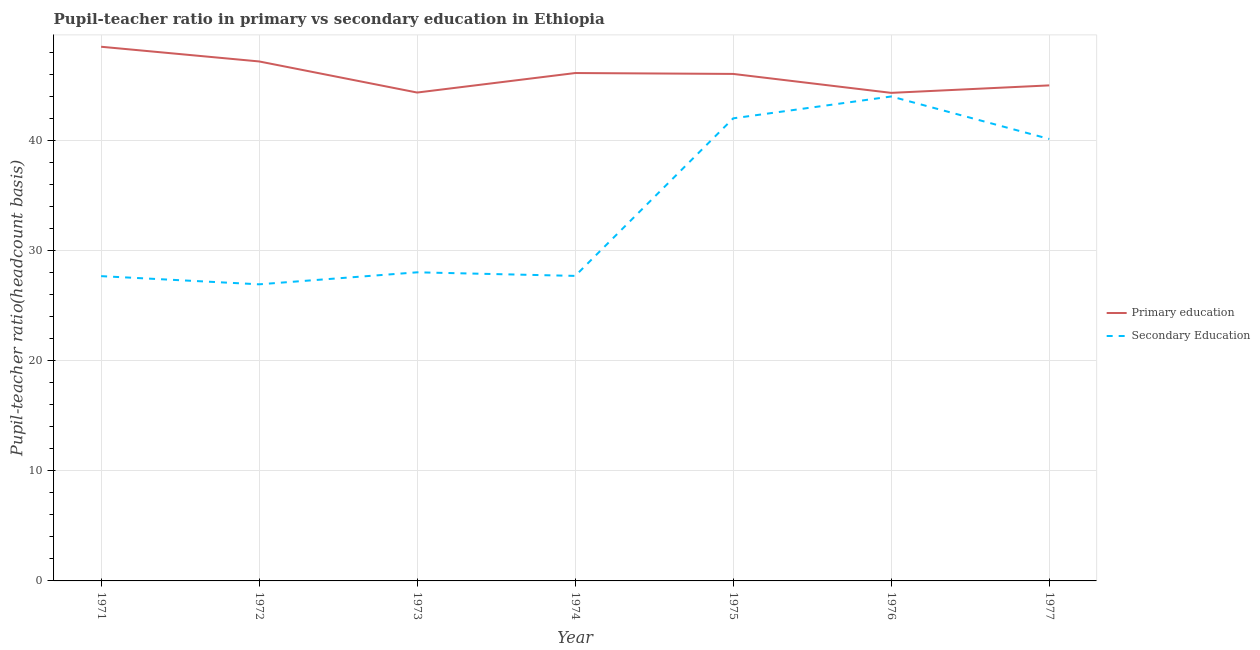How many different coloured lines are there?
Give a very brief answer. 2. What is the pupil teacher ratio on secondary education in 1977?
Give a very brief answer. 40.13. Across all years, what is the maximum pupil teacher ratio on secondary education?
Provide a succinct answer. 43.98. Across all years, what is the minimum pupil teacher ratio on secondary education?
Offer a terse response. 26.93. In which year was the pupil-teacher ratio in primary education maximum?
Make the answer very short. 1971. In which year was the pupil-teacher ratio in primary education minimum?
Your answer should be compact. 1976. What is the total pupil teacher ratio on secondary education in the graph?
Offer a very short reply. 236.43. What is the difference between the pupil teacher ratio on secondary education in 1972 and that in 1974?
Your answer should be compact. -0.76. What is the difference between the pupil teacher ratio on secondary education in 1971 and the pupil-teacher ratio in primary education in 1977?
Provide a short and direct response. -17.32. What is the average pupil-teacher ratio in primary education per year?
Keep it short and to the point. 45.92. In the year 1977, what is the difference between the pupil-teacher ratio in primary education and pupil teacher ratio on secondary education?
Keep it short and to the point. 4.86. What is the ratio of the pupil-teacher ratio in primary education in 1972 to that in 1976?
Your answer should be very brief. 1.06. What is the difference between the highest and the second highest pupil-teacher ratio in primary education?
Ensure brevity in your answer.  1.33. What is the difference between the highest and the lowest pupil teacher ratio on secondary education?
Give a very brief answer. 17.05. Is the pupil-teacher ratio in primary education strictly greater than the pupil teacher ratio on secondary education over the years?
Ensure brevity in your answer.  Yes. How many lines are there?
Keep it short and to the point. 2. Are the values on the major ticks of Y-axis written in scientific E-notation?
Your response must be concise. No. Does the graph contain grids?
Your answer should be compact. Yes. How are the legend labels stacked?
Provide a short and direct response. Vertical. What is the title of the graph?
Give a very brief answer. Pupil-teacher ratio in primary vs secondary education in Ethiopia. Does "Excluding technical cooperation" appear as one of the legend labels in the graph?
Ensure brevity in your answer.  No. What is the label or title of the X-axis?
Your response must be concise. Year. What is the label or title of the Y-axis?
Offer a very short reply. Pupil-teacher ratio(headcount basis). What is the Pupil-teacher ratio(headcount basis) of Primary education in 1971?
Provide a short and direct response. 48.5. What is the Pupil-teacher ratio(headcount basis) in Secondary Education in 1971?
Make the answer very short. 27.67. What is the Pupil-teacher ratio(headcount basis) of Primary education in 1972?
Your answer should be very brief. 47.17. What is the Pupil-teacher ratio(headcount basis) of Secondary Education in 1972?
Your answer should be very brief. 26.93. What is the Pupil-teacher ratio(headcount basis) in Primary education in 1973?
Offer a very short reply. 44.34. What is the Pupil-teacher ratio(headcount basis) in Secondary Education in 1973?
Offer a terse response. 28.02. What is the Pupil-teacher ratio(headcount basis) in Primary education in 1974?
Offer a very short reply. 46.11. What is the Pupil-teacher ratio(headcount basis) of Secondary Education in 1974?
Your answer should be compact. 27.69. What is the Pupil-teacher ratio(headcount basis) of Primary education in 1975?
Give a very brief answer. 46.03. What is the Pupil-teacher ratio(headcount basis) in Secondary Education in 1975?
Keep it short and to the point. 42. What is the Pupil-teacher ratio(headcount basis) in Primary education in 1976?
Ensure brevity in your answer.  44.31. What is the Pupil-teacher ratio(headcount basis) of Secondary Education in 1976?
Your response must be concise. 43.98. What is the Pupil-teacher ratio(headcount basis) in Primary education in 1977?
Give a very brief answer. 44.99. What is the Pupil-teacher ratio(headcount basis) in Secondary Education in 1977?
Offer a terse response. 40.13. Across all years, what is the maximum Pupil-teacher ratio(headcount basis) of Primary education?
Offer a very short reply. 48.5. Across all years, what is the maximum Pupil-teacher ratio(headcount basis) of Secondary Education?
Give a very brief answer. 43.98. Across all years, what is the minimum Pupil-teacher ratio(headcount basis) of Primary education?
Your response must be concise. 44.31. Across all years, what is the minimum Pupil-teacher ratio(headcount basis) in Secondary Education?
Offer a very short reply. 26.93. What is the total Pupil-teacher ratio(headcount basis) in Primary education in the graph?
Offer a very short reply. 321.46. What is the total Pupil-teacher ratio(headcount basis) of Secondary Education in the graph?
Keep it short and to the point. 236.43. What is the difference between the Pupil-teacher ratio(headcount basis) of Primary education in 1971 and that in 1972?
Your answer should be very brief. 1.33. What is the difference between the Pupil-teacher ratio(headcount basis) of Secondary Education in 1971 and that in 1972?
Your answer should be very brief. 0.74. What is the difference between the Pupil-teacher ratio(headcount basis) of Primary education in 1971 and that in 1973?
Offer a very short reply. 4.16. What is the difference between the Pupil-teacher ratio(headcount basis) of Secondary Education in 1971 and that in 1973?
Ensure brevity in your answer.  -0.35. What is the difference between the Pupil-teacher ratio(headcount basis) in Primary education in 1971 and that in 1974?
Give a very brief answer. 2.39. What is the difference between the Pupil-teacher ratio(headcount basis) in Secondary Education in 1971 and that in 1974?
Your response must be concise. -0.02. What is the difference between the Pupil-teacher ratio(headcount basis) of Primary education in 1971 and that in 1975?
Your answer should be very brief. 2.47. What is the difference between the Pupil-teacher ratio(headcount basis) of Secondary Education in 1971 and that in 1975?
Ensure brevity in your answer.  -14.33. What is the difference between the Pupil-teacher ratio(headcount basis) in Primary education in 1971 and that in 1976?
Offer a terse response. 4.19. What is the difference between the Pupil-teacher ratio(headcount basis) of Secondary Education in 1971 and that in 1976?
Provide a succinct answer. -16.31. What is the difference between the Pupil-teacher ratio(headcount basis) in Primary education in 1971 and that in 1977?
Your answer should be very brief. 3.51. What is the difference between the Pupil-teacher ratio(headcount basis) of Secondary Education in 1971 and that in 1977?
Ensure brevity in your answer.  -12.46. What is the difference between the Pupil-teacher ratio(headcount basis) of Primary education in 1972 and that in 1973?
Your answer should be very brief. 2.82. What is the difference between the Pupil-teacher ratio(headcount basis) of Secondary Education in 1972 and that in 1973?
Your answer should be compact. -1.09. What is the difference between the Pupil-teacher ratio(headcount basis) in Primary education in 1972 and that in 1974?
Your answer should be compact. 1.05. What is the difference between the Pupil-teacher ratio(headcount basis) in Secondary Education in 1972 and that in 1974?
Offer a terse response. -0.76. What is the difference between the Pupil-teacher ratio(headcount basis) of Primary education in 1972 and that in 1975?
Make the answer very short. 1.13. What is the difference between the Pupil-teacher ratio(headcount basis) of Secondary Education in 1972 and that in 1975?
Your answer should be compact. -15.07. What is the difference between the Pupil-teacher ratio(headcount basis) in Primary education in 1972 and that in 1976?
Provide a short and direct response. 2.85. What is the difference between the Pupil-teacher ratio(headcount basis) of Secondary Education in 1972 and that in 1976?
Your answer should be compact. -17.05. What is the difference between the Pupil-teacher ratio(headcount basis) in Primary education in 1972 and that in 1977?
Provide a short and direct response. 2.17. What is the difference between the Pupil-teacher ratio(headcount basis) in Secondary Education in 1972 and that in 1977?
Provide a succinct answer. -13.2. What is the difference between the Pupil-teacher ratio(headcount basis) in Primary education in 1973 and that in 1974?
Offer a terse response. -1.77. What is the difference between the Pupil-teacher ratio(headcount basis) of Secondary Education in 1973 and that in 1974?
Keep it short and to the point. 0.33. What is the difference between the Pupil-teacher ratio(headcount basis) in Primary education in 1973 and that in 1975?
Provide a short and direct response. -1.69. What is the difference between the Pupil-teacher ratio(headcount basis) in Secondary Education in 1973 and that in 1975?
Provide a short and direct response. -13.98. What is the difference between the Pupil-teacher ratio(headcount basis) in Primary education in 1973 and that in 1976?
Provide a succinct answer. 0.03. What is the difference between the Pupil-teacher ratio(headcount basis) in Secondary Education in 1973 and that in 1976?
Offer a terse response. -15.96. What is the difference between the Pupil-teacher ratio(headcount basis) of Primary education in 1973 and that in 1977?
Provide a succinct answer. -0.65. What is the difference between the Pupil-teacher ratio(headcount basis) in Secondary Education in 1973 and that in 1977?
Keep it short and to the point. -12.11. What is the difference between the Pupil-teacher ratio(headcount basis) in Primary education in 1974 and that in 1975?
Offer a very short reply. 0.08. What is the difference between the Pupil-teacher ratio(headcount basis) in Secondary Education in 1974 and that in 1975?
Offer a very short reply. -14.31. What is the difference between the Pupil-teacher ratio(headcount basis) in Primary education in 1974 and that in 1976?
Keep it short and to the point. 1.8. What is the difference between the Pupil-teacher ratio(headcount basis) of Secondary Education in 1974 and that in 1976?
Your answer should be very brief. -16.29. What is the difference between the Pupil-teacher ratio(headcount basis) in Primary education in 1974 and that in 1977?
Make the answer very short. 1.12. What is the difference between the Pupil-teacher ratio(headcount basis) in Secondary Education in 1974 and that in 1977?
Your answer should be very brief. -12.43. What is the difference between the Pupil-teacher ratio(headcount basis) of Primary education in 1975 and that in 1976?
Your answer should be very brief. 1.72. What is the difference between the Pupil-teacher ratio(headcount basis) in Secondary Education in 1975 and that in 1976?
Offer a very short reply. -1.98. What is the difference between the Pupil-teacher ratio(headcount basis) of Primary education in 1975 and that in 1977?
Make the answer very short. 1.04. What is the difference between the Pupil-teacher ratio(headcount basis) of Secondary Education in 1975 and that in 1977?
Your response must be concise. 1.87. What is the difference between the Pupil-teacher ratio(headcount basis) of Primary education in 1976 and that in 1977?
Ensure brevity in your answer.  -0.68. What is the difference between the Pupil-teacher ratio(headcount basis) in Secondary Education in 1976 and that in 1977?
Give a very brief answer. 3.86. What is the difference between the Pupil-teacher ratio(headcount basis) in Primary education in 1971 and the Pupil-teacher ratio(headcount basis) in Secondary Education in 1972?
Keep it short and to the point. 21.57. What is the difference between the Pupil-teacher ratio(headcount basis) of Primary education in 1971 and the Pupil-teacher ratio(headcount basis) of Secondary Education in 1973?
Offer a very short reply. 20.48. What is the difference between the Pupil-teacher ratio(headcount basis) in Primary education in 1971 and the Pupil-teacher ratio(headcount basis) in Secondary Education in 1974?
Ensure brevity in your answer.  20.8. What is the difference between the Pupil-teacher ratio(headcount basis) in Primary education in 1971 and the Pupil-teacher ratio(headcount basis) in Secondary Education in 1975?
Ensure brevity in your answer.  6.5. What is the difference between the Pupil-teacher ratio(headcount basis) in Primary education in 1971 and the Pupil-teacher ratio(headcount basis) in Secondary Education in 1976?
Provide a succinct answer. 4.51. What is the difference between the Pupil-teacher ratio(headcount basis) of Primary education in 1971 and the Pupil-teacher ratio(headcount basis) of Secondary Education in 1977?
Make the answer very short. 8.37. What is the difference between the Pupil-teacher ratio(headcount basis) in Primary education in 1972 and the Pupil-teacher ratio(headcount basis) in Secondary Education in 1973?
Make the answer very short. 19.15. What is the difference between the Pupil-teacher ratio(headcount basis) in Primary education in 1972 and the Pupil-teacher ratio(headcount basis) in Secondary Education in 1974?
Ensure brevity in your answer.  19.47. What is the difference between the Pupil-teacher ratio(headcount basis) in Primary education in 1972 and the Pupil-teacher ratio(headcount basis) in Secondary Education in 1975?
Ensure brevity in your answer.  5.17. What is the difference between the Pupil-teacher ratio(headcount basis) of Primary education in 1972 and the Pupil-teacher ratio(headcount basis) of Secondary Education in 1976?
Offer a terse response. 3.18. What is the difference between the Pupil-teacher ratio(headcount basis) of Primary education in 1972 and the Pupil-teacher ratio(headcount basis) of Secondary Education in 1977?
Keep it short and to the point. 7.04. What is the difference between the Pupil-teacher ratio(headcount basis) in Primary education in 1973 and the Pupil-teacher ratio(headcount basis) in Secondary Education in 1974?
Provide a short and direct response. 16.65. What is the difference between the Pupil-teacher ratio(headcount basis) of Primary education in 1973 and the Pupil-teacher ratio(headcount basis) of Secondary Education in 1975?
Keep it short and to the point. 2.34. What is the difference between the Pupil-teacher ratio(headcount basis) in Primary education in 1973 and the Pupil-teacher ratio(headcount basis) in Secondary Education in 1976?
Provide a succinct answer. 0.36. What is the difference between the Pupil-teacher ratio(headcount basis) of Primary education in 1973 and the Pupil-teacher ratio(headcount basis) of Secondary Education in 1977?
Your response must be concise. 4.21. What is the difference between the Pupil-teacher ratio(headcount basis) of Primary education in 1974 and the Pupil-teacher ratio(headcount basis) of Secondary Education in 1975?
Ensure brevity in your answer.  4.11. What is the difference between the Pupil-teacher ratio(headcount basis) of Primary education in 1974 and the Pupil-teacher ratio(headcount basis) of Secondary Education in 1976?
Ensure brevity in your answer.  2.13. What is the difference between the Pupil-teacher ratio(headcount basis) in Primary education in 1974 and the Pupil-teacher ratio(headcount basis) in Secondary Education in 1977?
Offer a very short reply. 5.99. What is the difference between the Pupil-teacher ratio(headcount basis) in Primary education in 1975 and the Pupil-teacher ratio(headcount basis) in Secondary Education in 1976?
Your answer should be compact. 2.05. What is the difference between the Pupil-teacher ratio(headcount basis) of Primary education in 1975 and the Pupil-teacher ratio(headcount basis) of Secondary Education in 1977?
Your answer should be very brief. 5.91. What is the difference between the Pupil-teacher ratio(headcount basis) of Primary education in 1976 and the Pupil-teacher ratio(headcount basis) of Secondary Education in 1977?
Keep it short and to the point. 4.19. What is the average Pupil-teacher ratio(headcount basis) in Primary education per year?
Make the answer very short. 45.92. What is the average Pupil-teacher ratio(headcount basis) of Secondary Education per year?
Make the answer very short. 33.78. In the year 1971, what is the difference between the Pupil-teacher ratio(headcount basis) in Primary education and Pupil-teacher ratio(headcount basis) in Secondary Education?
Ensure brevity in your answer.  20.83. In the year 1972, what is the difference between the Pupil-teacher ratio(headcount basis) of Primary education and Pupil-teacher ratio(headcount basis) of Secondary Education?
Offer a very short reply. 20.24. In the year 1973, what is the difference between the Pupil-teacher ratio(headcount basis) of Primary education and Pupil-teacher ratio(headcount basis) of Secondary Education?
Offer a terse response. 16.32. In the year 1974, what is the difference between the Pupil-teacher ratio(headcount basis) in Primary education and Pupil-teacher ratio(headcount basis) in Secondary Education?
Your response must be concise. 18.42. In the year 1975, what is the difference between the Pupil-teacher ratio(headcount basis) in Primary education and Pupil-teacher ratio(headcount basis) in Secondary Education?
Make the answer very short. 4.03. In the year 1976, what is the difference between the Pupil-teacher ratio(headcount basis) of Primary education and Pupil-teacher ratio(headcount basis) of Secondary Education?
Keep it short and to the point. 0.33. In the year 1977, what is the difference between the Pupil-teacher ratio(headcount basis) of Primary education and Pupil-teacher ratio(headcount basis) of Secondary Education?
Keep it short and to the point. 4.86. What is the ratio of the Pupil-teacher ratio(headcount basis) of Primary education in 1971 to that in 1972?
Keep it short and to the point. 1.03. What is the ratio of the Pupil-teacher ratio(headcount basis) of Secondary Education in 1971 to that in 1972?
Make the answer very short. 1.03. What is the ratio of the Pupil-teacher ratio(headcount basis) in Primary education in 1971 to that in 1973?
Provide a short and direct response. 1.09. What is the ratio of the Pupil-teacher ratio(headcount basis) in Secondary Education in 1971 to that in 1973?
Provide a short and direct response. 0.99. What is the ratio of the Pupil-teacher ratio(headcount basis) of Primary education in 1971 to that in 1974?
Your response must be concise. 1.05. What is the ratio of the Pupil-teacher ratio(headcount basis) in Primary education in 1971 to that in 1975?
Ensure brevity in your answer.  1.05. What is the ratio of the Pupil-teacher ratio(headcount basis) of Secondary Education in 1971 to that in 1975?
Give a very brief answer. 0.66. What is the ratio of the Pupil-teacher ratio(headcount basis) in Primary education in 1971 to that in 1976?
Give a very brief answer. 1.09. What is the ratio of the Pupil-teacher ratio(headcount basis) of Secondary Education in 1971 to that in 1976?
Give a very brief answer. 0.63. What is the ratio of the Pupil-teacher ratio(headcount basis) of Primary education in 1971 to that in 1977?
Offer a very short reply. 1.08. What is the ratio of the Pupil-teacher ratio(headcount basis) of Secondary Education in 1971 to that in 1977?
Give a very brief answer. 0.69. What is the ratio of the Pupil-teacher ratio(headcount basis) of Primary education in 1972 to that in 1973?
Your response must be concise. 1.06. What is the ratio of the Pupil-teacher ratio(headcount basis) in Secondary Education in 1972 to that in 1973?
Keep it short and to the point. 0.96. What is the ratio of the Pupil-teacher ratio(headcount basis) of Primary education in 1972 to that in 1974?
Keep it short and to the point. 1.02. What is the ratio of the Pupil-teacher ratio(headcount basis) in Secondary Education in 1972 to that in 1974?
Your response must be concise. 0.97. What is the ratio of the Pupil-teacher ratio(headcount basis) of Primary education in 1972 to that in 1975?
Keep it short and to the point. 1.02. What is the ratio of the Pupil-teacher ratio(headcount basis) in Secondary Education in 1972 to that in 1975?
Provide a succinct answer. 0.64. What is the ratio of the Pupil-teacher ratio(headcount basis) in Primary education in 1972 to that in 1976?
Give a very brief answer. 1.06. What is the ratio of the Pupil-teacher ratio(headcount basis) in Secondary Education in 1972 to that in 1976?
Your answer should be compact. 0.61. What is the ratio of the Pupil-teacher ratio(headcount basis) of Primary education in 1972 to that in 1977?
Ensure brevity in your answer.  1.05. What is the ratio of the Pupil-teacher ratio(headcount basis) in Secondary Education in 1972 to that in 1977?
Offer a terse response. 0.67. What is the ratio of the Pupil-teacher ratio(headcount basis) of Primary education in 1973 to that in 1974?
Offer a terse response. 0.96. What is the ratio of the Pupil-teacher ratio(headcount basis) of Secondary Education in 1973 to that in 1974?
Provide a succinct answer. 1.01. What is the ratio of the Pupil-teacher ratio(headcount basis) of Primary education in 1973 to that in 1975?
Offer a terse response. 0.96. What is the ratio of the Pupil-teacher ratio(headcount basis) in Secondary Education in 1973 to that in 1975?
Provide a succinct answer. 0.67. What is the ratio of the Pupil-teacher ratio(headcount basis) in Primary education in 1973 to that in 1976?
Your answer should be very brief. 1. What is the ratio of the Pupil-teacher ratio(headcount basis) of Secondary Education in 1973 to that in 1976?
Provide a short and direct response. 0.64. What is the ratio of the Pupil-teacher ratio(headcount basis) of Primary education in 1973 to that in 1977?
Your answer should be very brief. 0.99. What is the ratio of the Pupil-teacher ratio(headcount basis) of Secondary Education in 1973 to that in 1977?
Your response must be concise. 0.7. What is the ratio of the Pupil-teacher ratio(headcount basis) of Secondary Education in 1974 to that in 1975?
Provide a short and direct response. 0.66. What is the ratio of the Pupil-teacher ratio(headcount basis) in Primary education in 1974 to that in 1976?
Your answer should be very brief. 1.04. What is the ratio of the Pupil-teacher ratio(headcount basis) in Secondary Education in 1974 to that in 1976?
Your answer should be compact. 0.63. What is the ratio of the Pupil-teacher ratio(headcount basis) of Primary education in 1974 to that in 1977?
Provide a short and direct response. 1.02. What is the ratio of the Pupil-teacher ratio(headcount basis) of Secondary Education in 1974 to that in 1977?
Offer a very short reply. 0.69. What is the ratio of the Pupil-teacher ratio(headcount basis) in Primary education in 1975 to that in 1976?
Your answer should be very brief. 1.04. What is the ratio of the Pupil-teacher ratio(headcount basis) in Secondary Education in 1975 to that in 1976?
Provide a short and direct response. 0.95. What is the ratio of the Pupil-teacher ratio(headcount basis) in Primary education in 1975 to that in 1977?
Provide a short and direct response. 1.02. What is the ratio of the Pupil-teacher ratio(headcount basis) of Secondary Education in 1975 to that in 1977?
Keep it short and to the point. 1.05. What is the ratio of the Pupil-teacher ratio(headcount basis) in Primary education in 1976 to that in 1977?
Offer a very short reply. 0.98. What is the ratio of the Pupil-teacher ratio(headcount basis) of Secondary Education in 1976 to that in 1977?
Your answer should be compact. 1.1. What is the difference between the highest and the second highest Pupil-teacher ratio(headcount basis) of Primary education?
Keep it short and to the point. 1.33. What is the difference between the highest and the second highest Pupil-teacher ratio(headcount basis) in Secondary Education?
Make the answer very short. 1.98. What is the difference between the highest and the lowest Pupil-teacher ratio(headcount basis) in Primary education?
Keep it short and to the point. 4.19. What is the difference between the highest and the lowest Pupil-teacher ratio(headcount basis) in Secondary Education?
Ensure brevity in your answer.  17.05. 